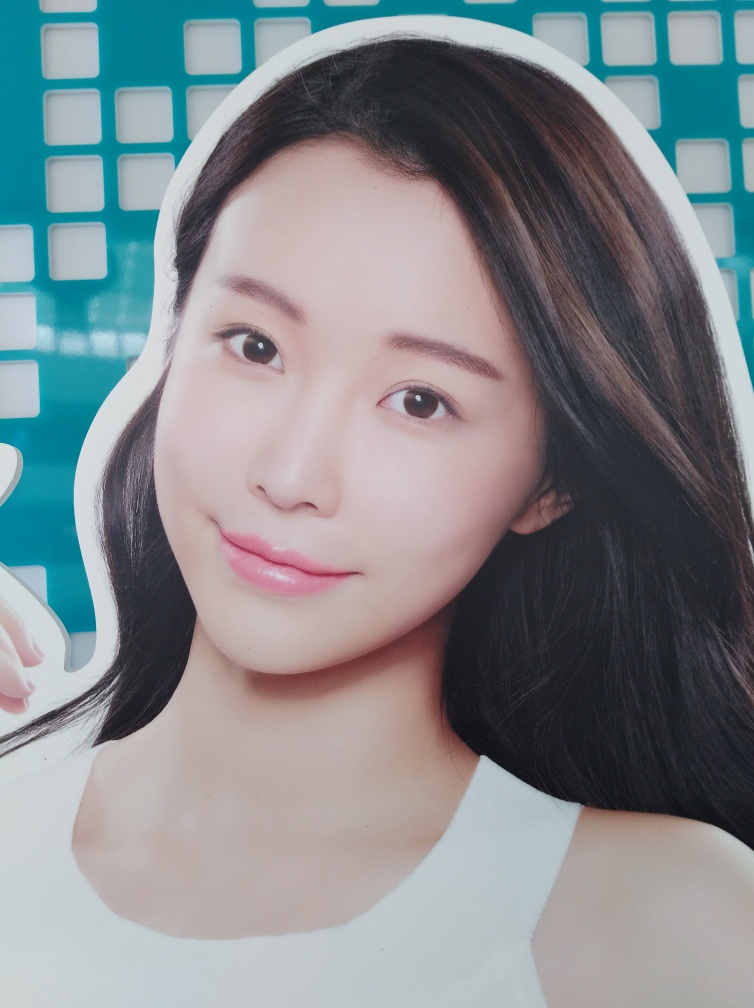Is there anything unique about the composition of this advertisement? The composition uses a close-up of the model's face to draw focus to the facial features, promoting the idea of beauty and skincare effectiveness. The background employs a geometric pattern, potentially to convey a sense of order and reliability. 